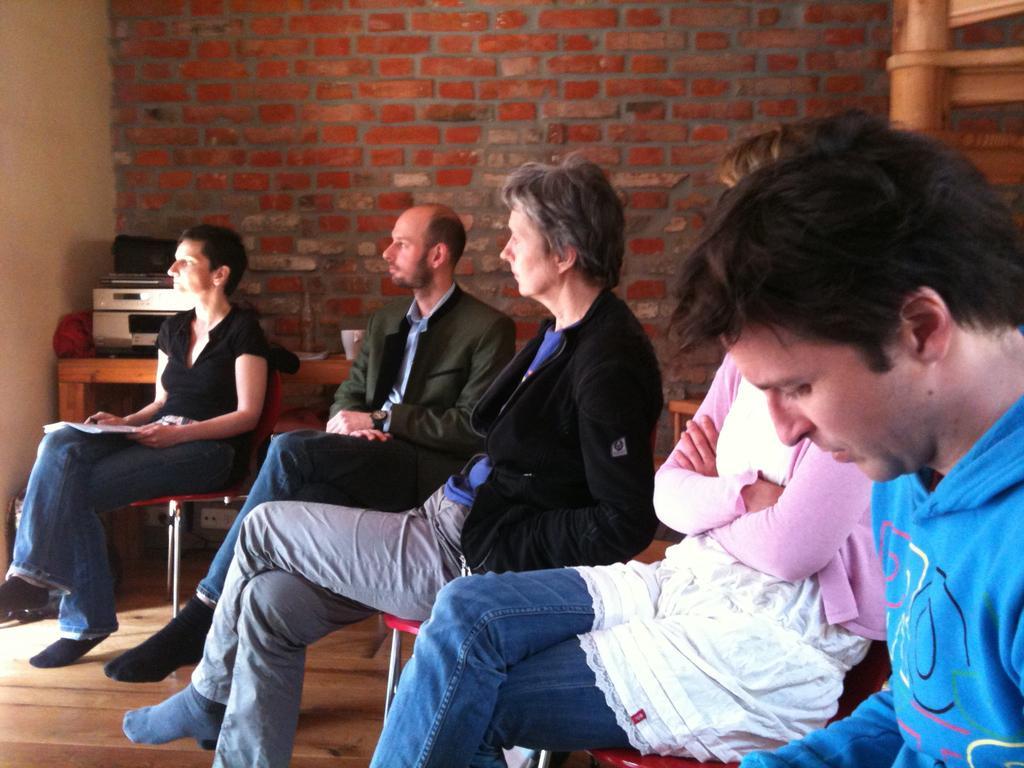How would you summarize this image in a sentence or two? In this image we can see a group of people sitting on chairs placed on the floor. One woman is holding a book in her hand. In the background, we can see a device, paper and cup placed on the table, staircase and the wall. 